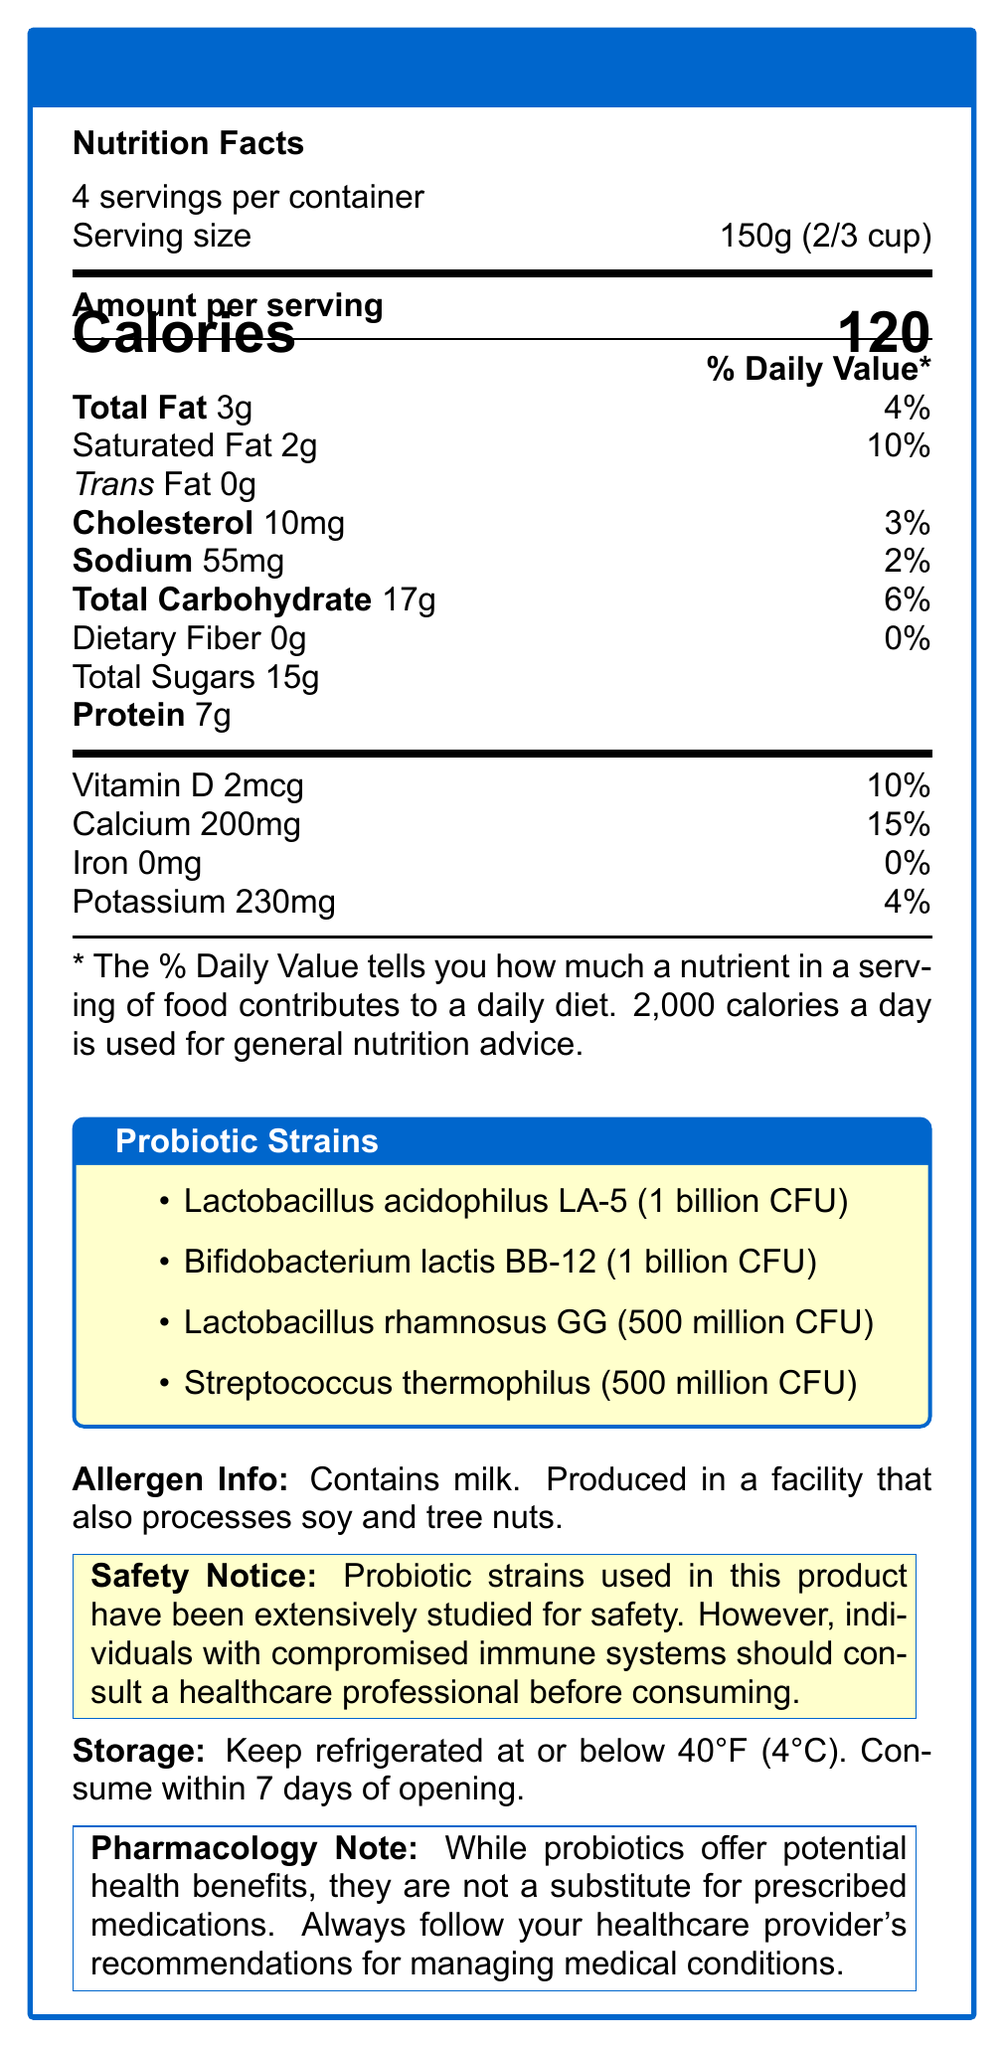what is the serving size for the ProBiotic Boost Yogurt? The document specifies that the serving size is 150g or 2/3 cup.
Answer: 150g (2/3 cup) how many servings are contained in one package of ProBiotic Boost Yogurt? The document states that there are 4 servings per container.
Answer: 4 how much cholesterol is in one serving of ProBiotic Boost Yogurt? The document notes that there are 10mg of cholesterol per serving.
Answer: 10mg name one probiotic strain in ProBiotic Boost Yogurt that may help prevent and treat diarrhea, particularly in children. According to the document, Lactobacillus rhamnosus GG may help prevent and treat diarrhea, particularly in children.
Answer: Lactobacillus rhamnosus GG is the product suitable for individuals with compromised immune systems to consume without consultation? The Safety Notice in the document advises consulting a healthcare professional before consuming this product if one has a compromised immune system.
Answer: No how many Calories are in one serving of ProBiotic Boost Yogurt? The document specifies that there are 120 Calories per serving.
Answer: 120 what is the potential health benefit of consuming Lactobacillus acidophilus LA-5? The document states that Lactobacillus acidophilus LA-5 may improve digestive health and boost immune function.
Answer: May improve digestive health and boost immune function which of these bacteria is present in the highest concentration in ProBiotic Boost Yogurt? A. Bifidobacterium lactis BB-12, B. Streptococcus thermophilus, C. Lactobacillus rhamnosus GG Bifidobacterium lactis BB-12 is present at 1 billion CFU, which is higher than the 500 million CFU for Streptococcus thermophilus and Lactobacillus rhamnosus GG.
Answer: A the ProBiotic Boost Yogurt contains which of the following allergens? A. Milk, B. Soy, C. Tree nuts, D. All of the above The document states that the product contains milk and is produced in a facility that processes soy and tree nuts.
Answer: D is iron present in ProBiotic Boost Yogurt in any significant amount? The document lists that the iron content is 0mg.
Answer: No summarize the main nutritional and probiotic features of ProBiotic Boost Yogurt. The document highlights the nutritional content including calories, fats, proteins, and vitamins, as well as the specific probiotic strains included and their potential health benefits.
Answer: ProBiotic Boost Yogurt provides 120 calories per serving, with significant amounts of protein (7g), calcium (200mg), and various other nutrients. It contains multiple probiotic strains such as Lactobacillus acidophilus LA-5, Bifidobacterium lactis BB-12, Lactobacillus rhamnosus GG, and Streptococcus thermophilus, each offering potential health benefits including improved digestive health, boosted immune function, and reduced gastrointestinal discomfort. what is the daily value percentage of calcium in one serving of ProBiotic Boost Yogurt? The document lists the daily value percentage for calcium as 15%.
Answer: 15% identify the storage instructions for keeping ProBiotic Boost Yogurt fresh. The document specifies these instructions under the storage section.
Answer: Keep refrigerated at or below 40°F (4°C). Consume within 7 days of opening. does the document indicate how Lactobacillus acidophilus LA-5 contributes to cardiovascular health? The document does not provide specific information about the contribution of Lactobacillus acidophilus LA-5 to cardiovascular health; it only mentions digestive health and immune function.
Answer: Not enough information can Lactobacillus rhamnosus GG potentially aid in lactose digestion? According to the document, Streptococcus thermophilus can aid in lactose digestion, not Lactobacillus rhamnosus GG.
Answer: No 